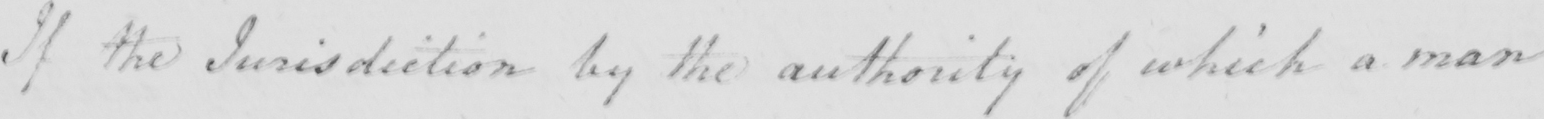Please transcribe the handwritten text in this image. If the Jurisdiction by the authority of which a man 